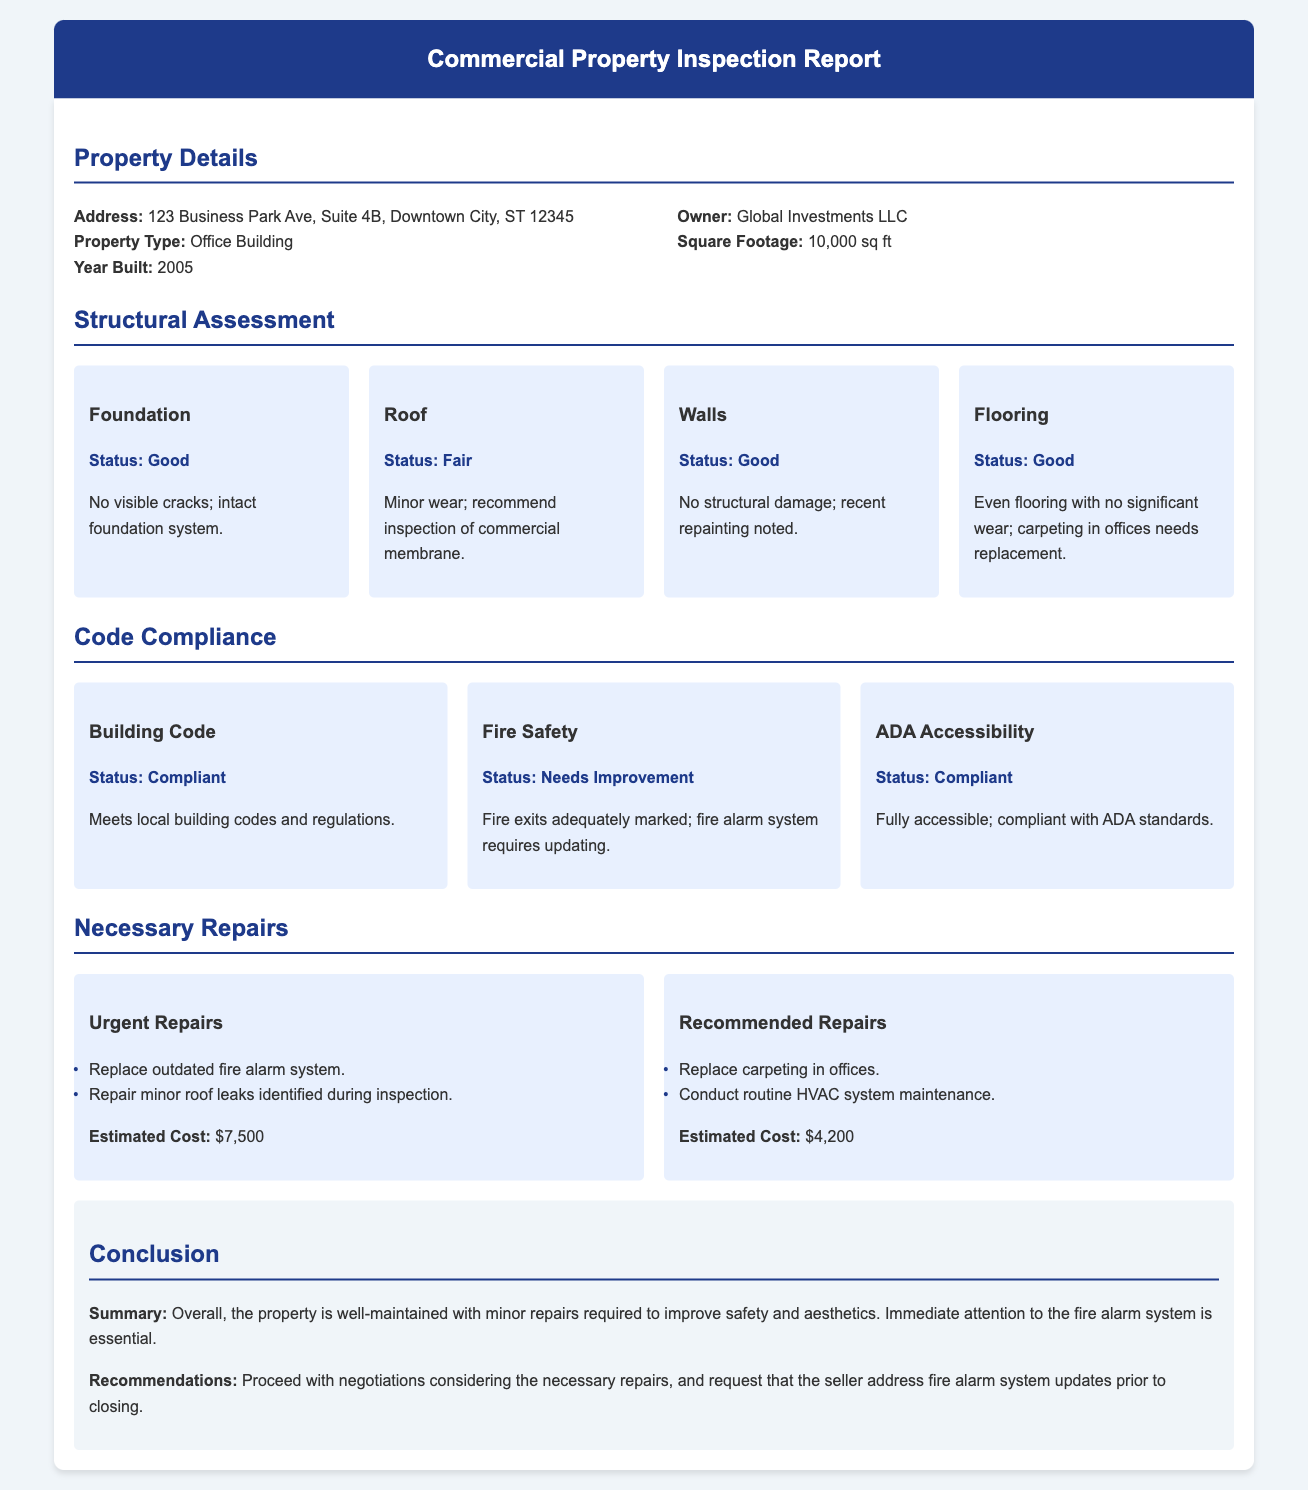What is the address of the property? The address is specified in the property details section of the document.
Answer: 123 Business Park Ave, Suite 4B, Downtown City, ST 12345 Who is the property owner? The owner's name is listed under the property details section.
Answer: Global Investments LLC What is the status of the foundation? The status is provided in the structural assessment section regarding the foundation.
Answer: Good What is the estimated cost for urgent repairs? The estimated cost for urgent repairs is mentioned in the necessary repairs section.
Answer: $7,500 How many square feet is the property? The square footage of the property is included in the property details.
Answer: 10,000 sq ft What improvement is needed for fire safety? The fire safety section indicates what needs to be changed for compliance.
Answer: Fire alarm system requires updating What type of property is listed? The type of property is defined in the property details section.
Answer: Office Building What is the conclusion about the property's maintenance? The conclusion provides an overall assessment of the property's condition.
Answer: Well-maintained with minor repairs required What is one of the recommended repairs? The necessary repairs section lists items that should be addressed.
Answer: Replace carpeting in offices 